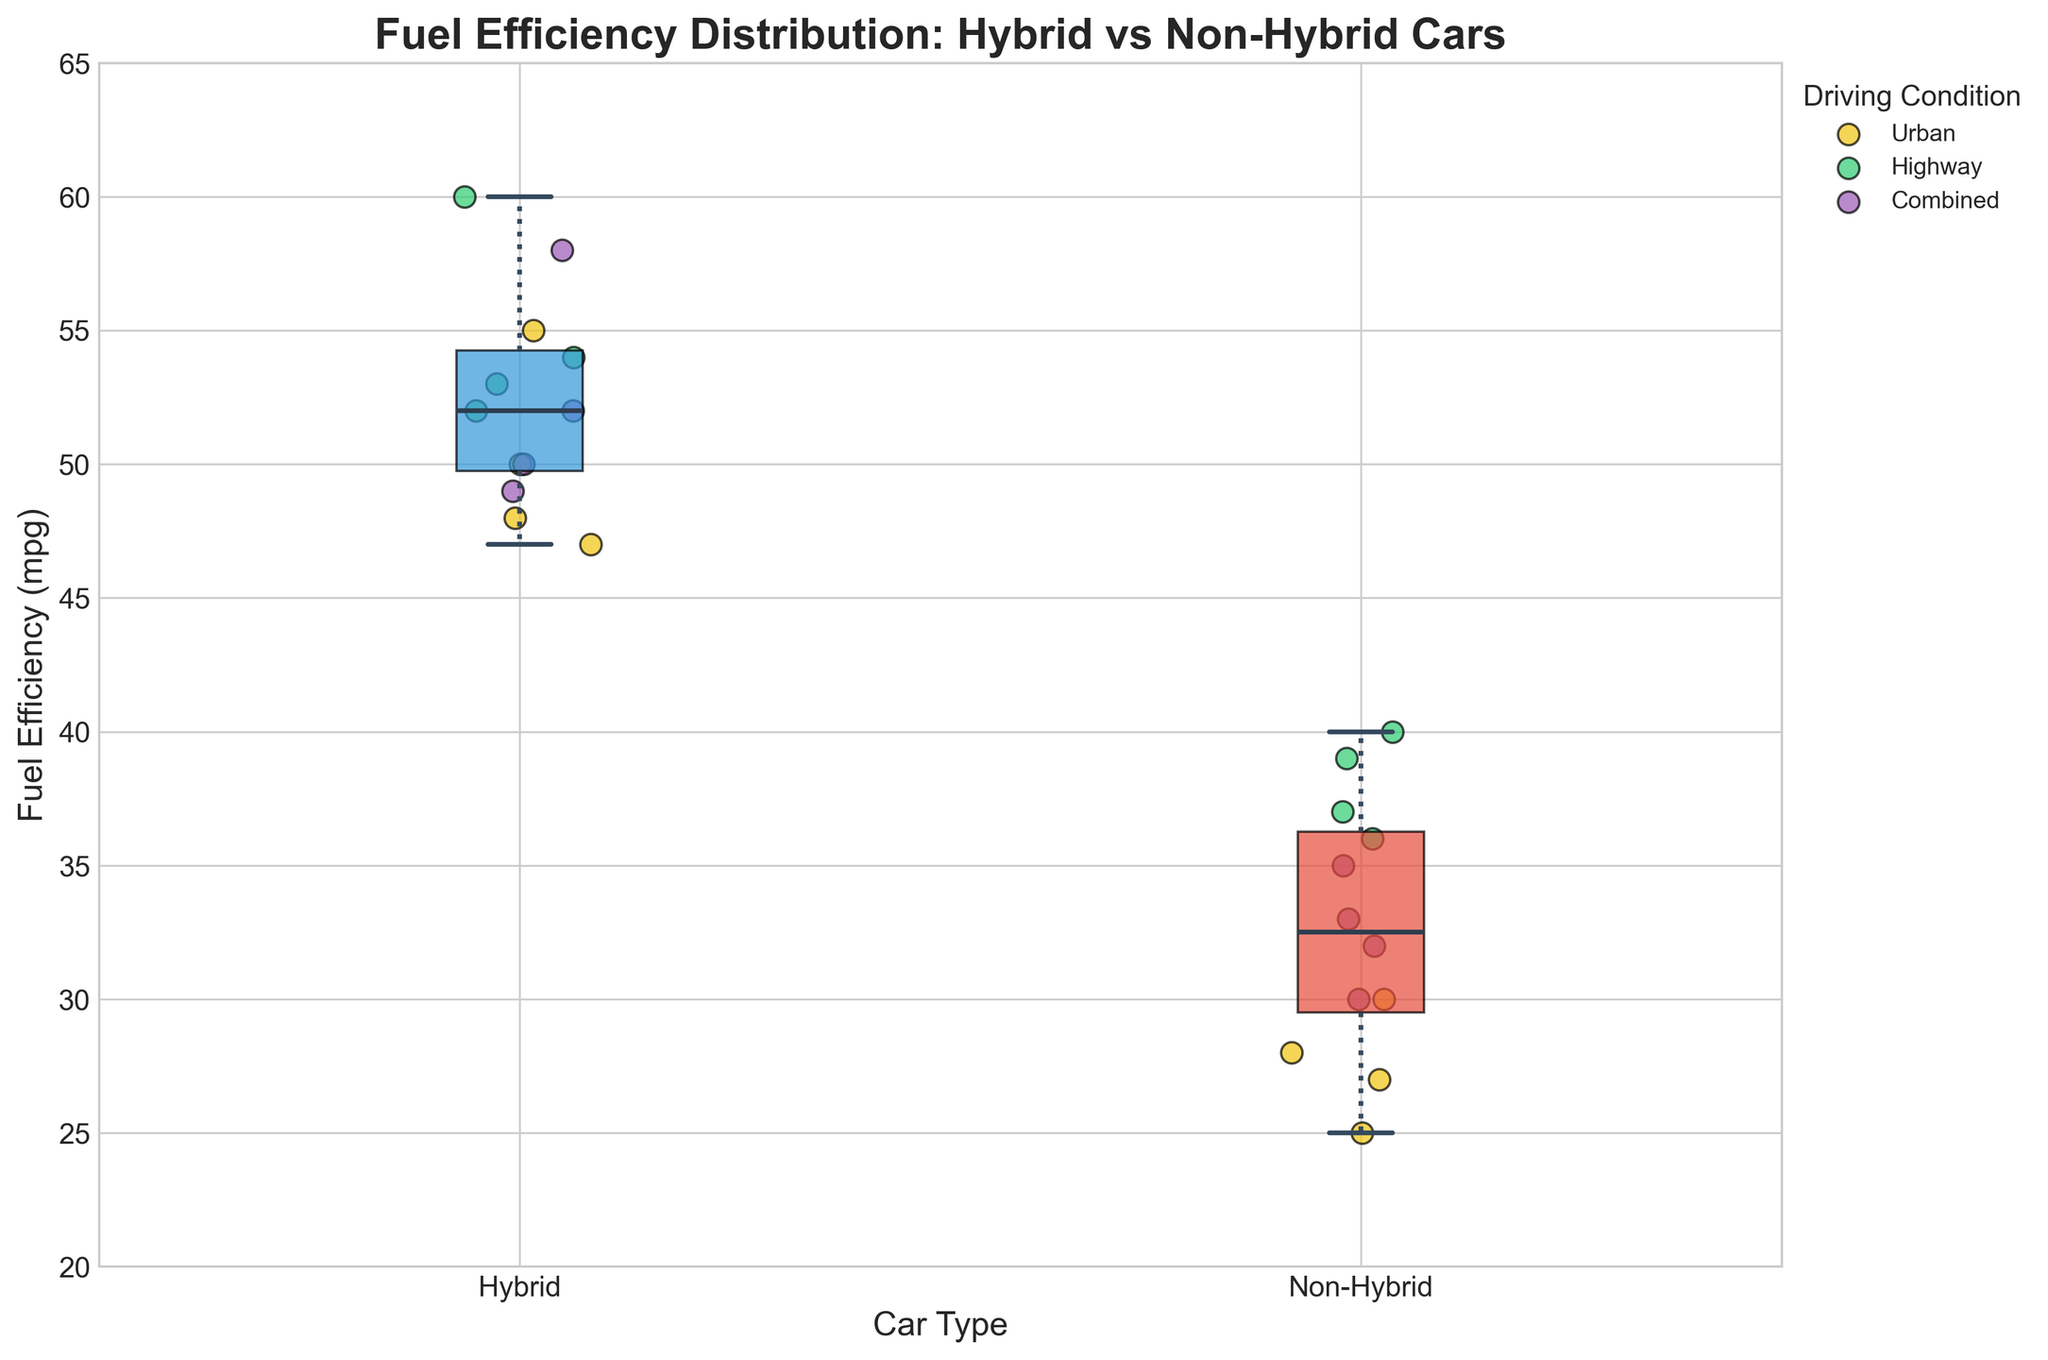How many unique driving conditions are represented by scatter points? The colors and legend indicate three unique driving conditions: Urban, Highway, and Combined.
Answer: 3 What is the median fuel efficiency of non-hybrid cars? Locate the median line within the Non-Hybrid box; it is around 33 mpg.
Answer: 33 mpg Which driving condition has the highest variance for hybrid cars? Observe how spread out the scatter points are for each driving condition for hybrid cars. Urban conditions have the widest spread from approximately 47 to 55 mpg, suggesting the highest variance.
Answer: Urban Between hybrid and non-hybrid cars, which category tends to be more fuel-efficient? Compare the overall position and spread of the boxes; the Hybrid box is higher on the y-axis, indicating greater fuel efficiency.
Answer: Hybrid What is the maximum fuel efficiency recorded for non-hybrid cars under any driving condition? Check the highest scatter point among non-hybrids; it is observed on the Highway condition at 40 mpg.
Answer: 40 mpg Which has a higher median fuel efficiency: Hybrid or Non-Hybrid cars? Compare the central line in both boxes; Hybrid cars have a higher median value.
Answer: Hybrid Are there any overlapping fuel efficiency values between hybrid and non-hybrid cars? If so, in which range? Examine the range of values covered by both boxes; there is an overlap roughly in the 30-40 mpg range.
Answer: 30-40 mpg What is the color used to denote the Highway driving condition in the scatter points? The legend indicates that the Highway driving condition is marked with a green color.
Answer: Green What is the approximate interquartile range (IQR) for hybrid cars' fuel efficiency? Identify the edges of the box for Hybrids; the lower end (Q1) is around 49 mpg, and the higher end (Q3) is around 54 mpg. Thus, IQR = Q3 - Q1 = 54 - 49 = 5 mpg.
Answer: 5 mpg How does the fuel efficiency of non-hybrid cars vary with driving conditions? Non-hybrid cars' scatter points show that Highway driving condition has the highest fuel efficiency, followed by Combined, and then Urban.
Answer: Highway > Combined > Urban 